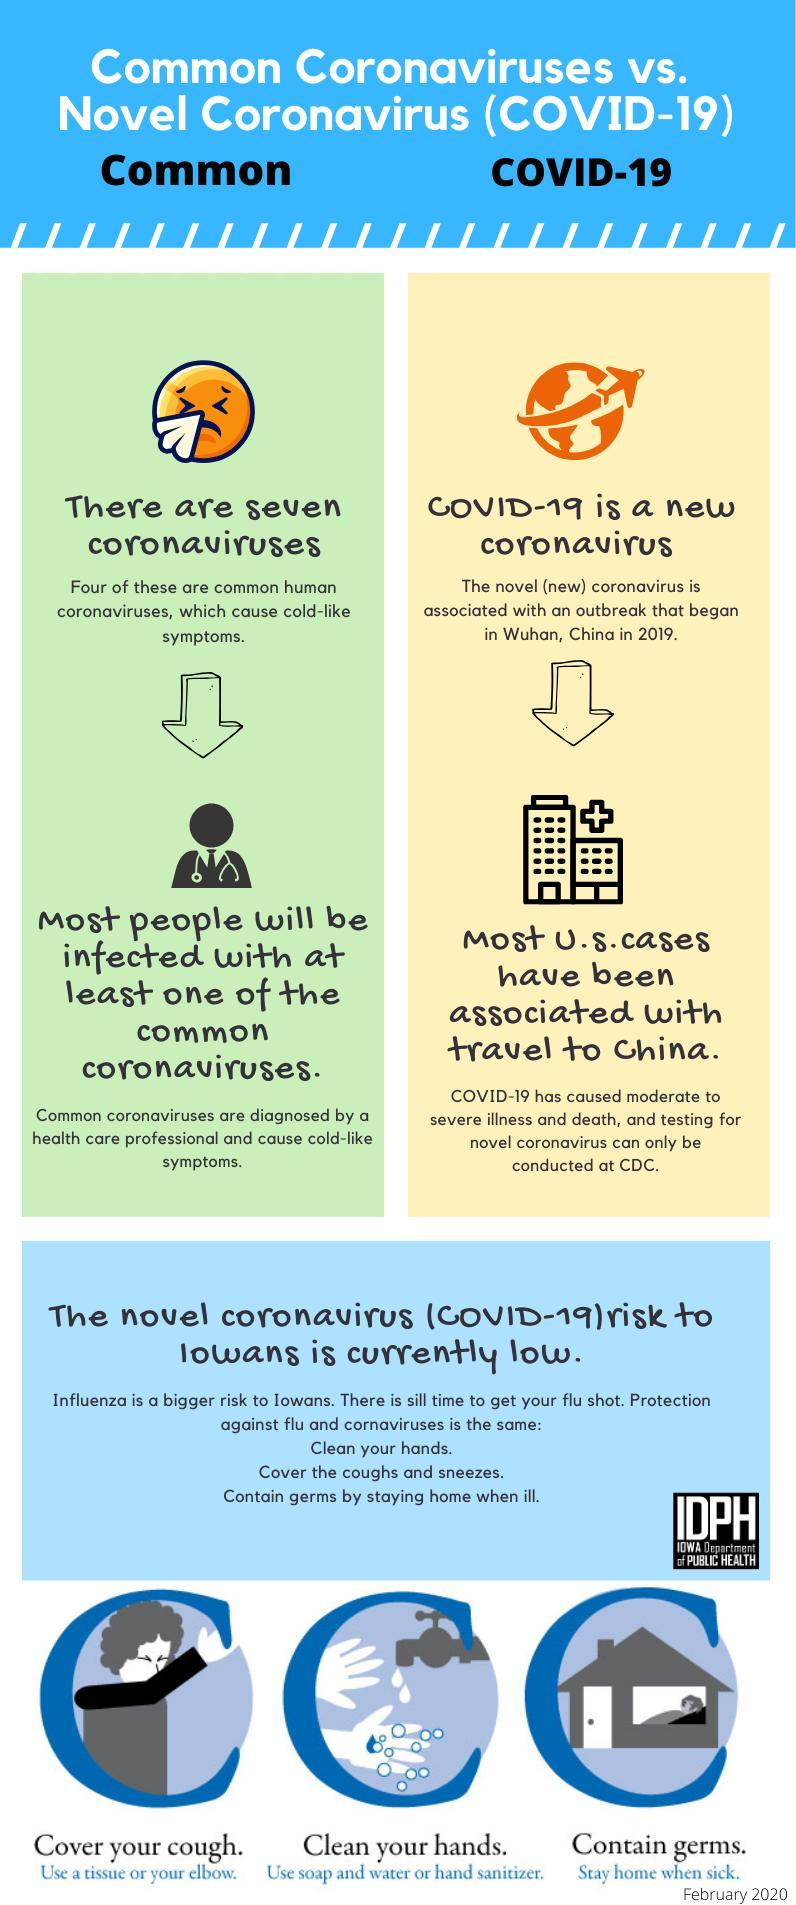Out of 7, how many types of common coronavirus didn't have cold-like symptoms?
Answer the question with a short phrase. 3 